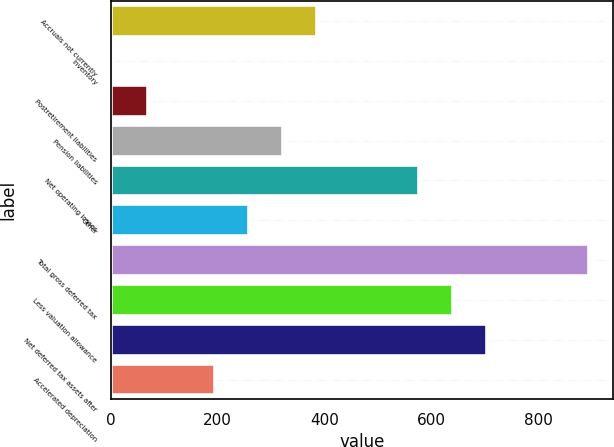Convert chart to OTSL. <chart><loc_0><loc_0><loc_500><loc_500><bar_chart><fcel>Accruals not currently<fcel>Inventory<fcel>Postretirement liabilities<fcel>Pension liabilities<fcel>Net operating losses<fcel>Other<fcel>Total gross deferred tax<fcel>Less valuation allowance<fcel>Net deferred tax assets after<fcel>Accelerated depreciation<nl><fcel>386.46<fcel>4.8<fcel>68.41<fcel>322.85<fcel>577.29<fcel>259.24<fcel>895.34<fcel>640.9<fcel>704.51<fcel>195.63<nl></chart> 